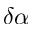<formula> <loc_0><loc_0><loc_500><loc_500>\delta \alpha</formula> 